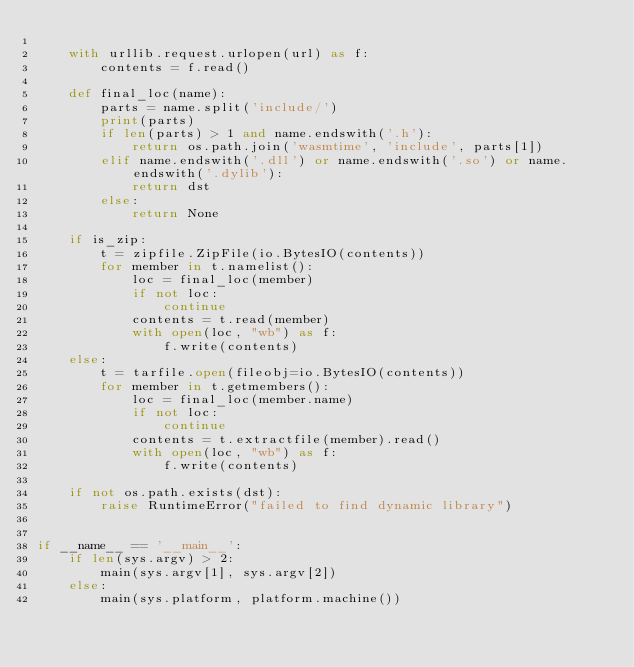<code> <loc_0><loc_0><loc_500><loc_500><_Python_>
    with urllib.request.urlopen(url) as f:
        contents = f.read()

    def final_loc(name):
        parts = name.split('include/')
        print(parts)
        if len(parts) > 1 and name.endswith('.h'):
            return os.path.join('wasmtime', 'include', parts[1])
        elif name.endswith('.dll') or name.endswith('.so') or name.endswith('.dylib'):
            return dst
        else:
            return None

    if is_zip:
        t = zipfile.ZipFile(io.BytesIO(contents))
        for member in t.namelist():
            loc = final_loc(member)
            if not loc:
                continue
            contents = t.read(member)
            with open(loc, "wb") as f:
                f.write(contents)
    else:
        t = tarfile.open(fileobj=io.BytesIO(contents))
        for member in t.getmembers():
            loc = final_loc(member.name)
            if not loc:
                continue
            contents = t.extractfile(member).read()
            with open(loc, "wb") as f:
                f.write(contents)

    if not os.path.exists(dst):
        raise RuntimeError("failed to find dynamic library")


if __name__ == '__main__':
    if len(sys.argv) > 2:
        main(sys.argv[1], sys.argv[2])
    else:
        main(sys.platform, platform.machine())
</code> 